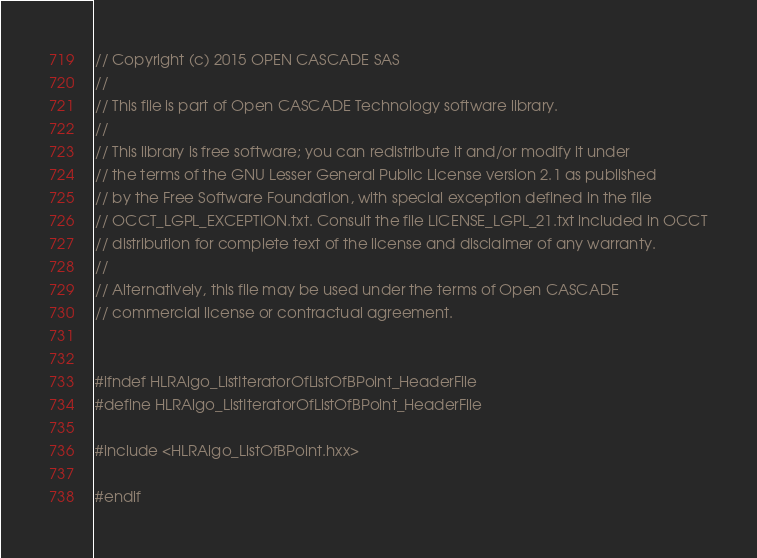<code> <loc_0><loc_0><loc_500><loc_500><_C++_>// Copyright (c) 2015 OPEN CASCADE SAS
//
// This file is part of Open CASCADE Technology software library.
//
// This library is free software; you can redistribute it and/or modify it under
// the terms of the GNU Lesser General Public License version 2.1 as published
// by the Free Software Foundation, with special exception defined in the file
// OCCT_LGPL_EXCEPTION.txt. Consult the file LICENSE_LGPL_21.txt included in OCCT
// distribution for complete text of the license and disclaimer of any warranty.
//
// Alternatively, this file may be used under the terms of Open CASCADE
// commercial license or contractual agreement.


#ifndef HLRAlgo_ListIteratorOfListOfBPoint_HeaderFile
#define HLRAlgo_ListIteratorOfListOfBPoint_HeaderFile

#include <HLRAlgo_ListOfBPoint.hxx>

#endif
</code> 